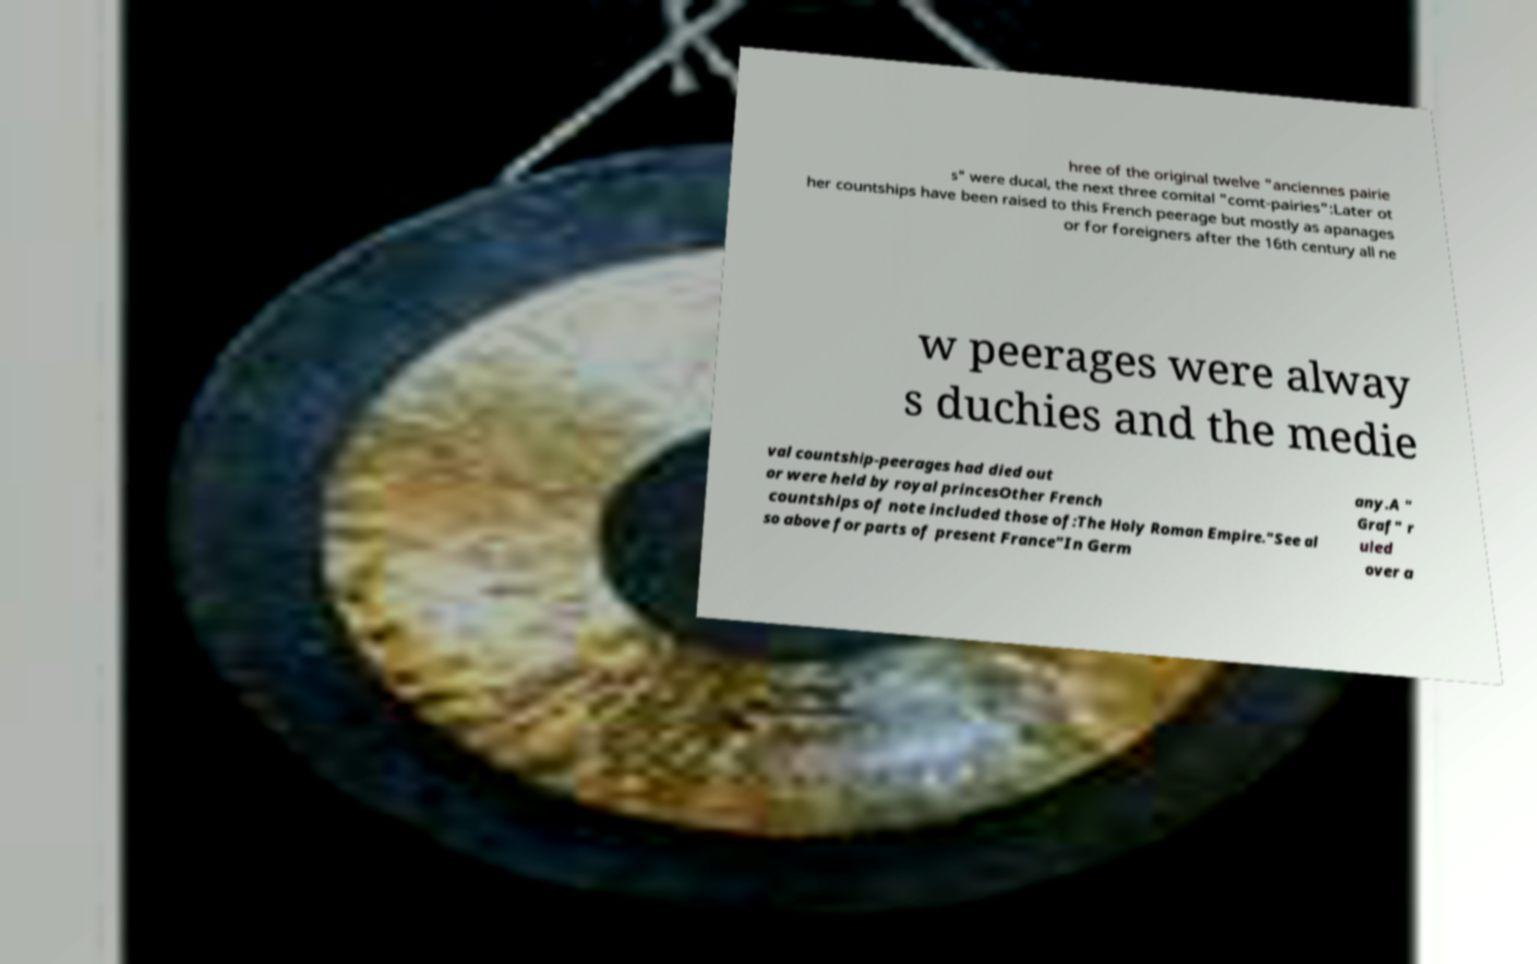Can you accurately transcribe the text from the provided image for me? hree of the original twelve "anciennes pairie s" were ducal, the next three comital "comt-pairies":Later ot her countships have been raised to this French peerage but mostly as apanages or for foreigners after the 16th century all ne w peerages were alway s duchies and the medie val countship-peerages had died out or were held by royal princesOther French countships of note included those of:The Holy Roman Empire."See al so above for parts of present France"In Germ any.A " Graf" r uled over a 